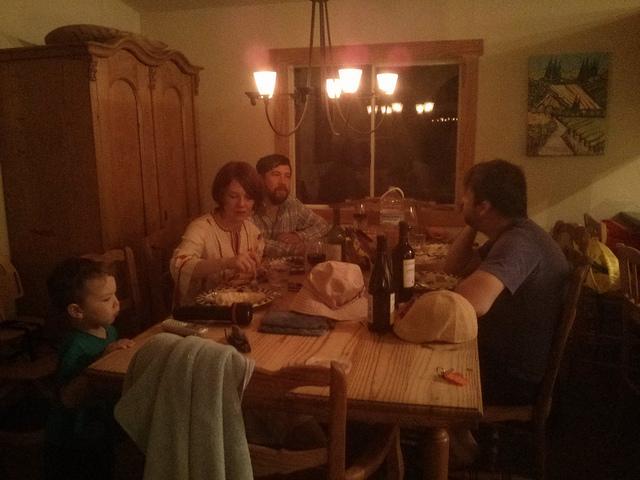Is it a packed house?
Quick response, please. No. What are they staring at?
Short answer required. Food. How many hats are in the picture?
Quick response, please. 2. Is there a big TV in the picture?
Short answer required. No. What is the color of the house?
Concise answer only. White. What kind of bottles are on the table?
Be succinct. Wine. What is on top of the China cabinet?
Concise answer only. Nothing. How many children are at the table?
Give a very brief answer. 1. Is anyone recording this scene?
Quick response, please. No. What beverage will not be served to the child?
Quick response, please. Wine. 